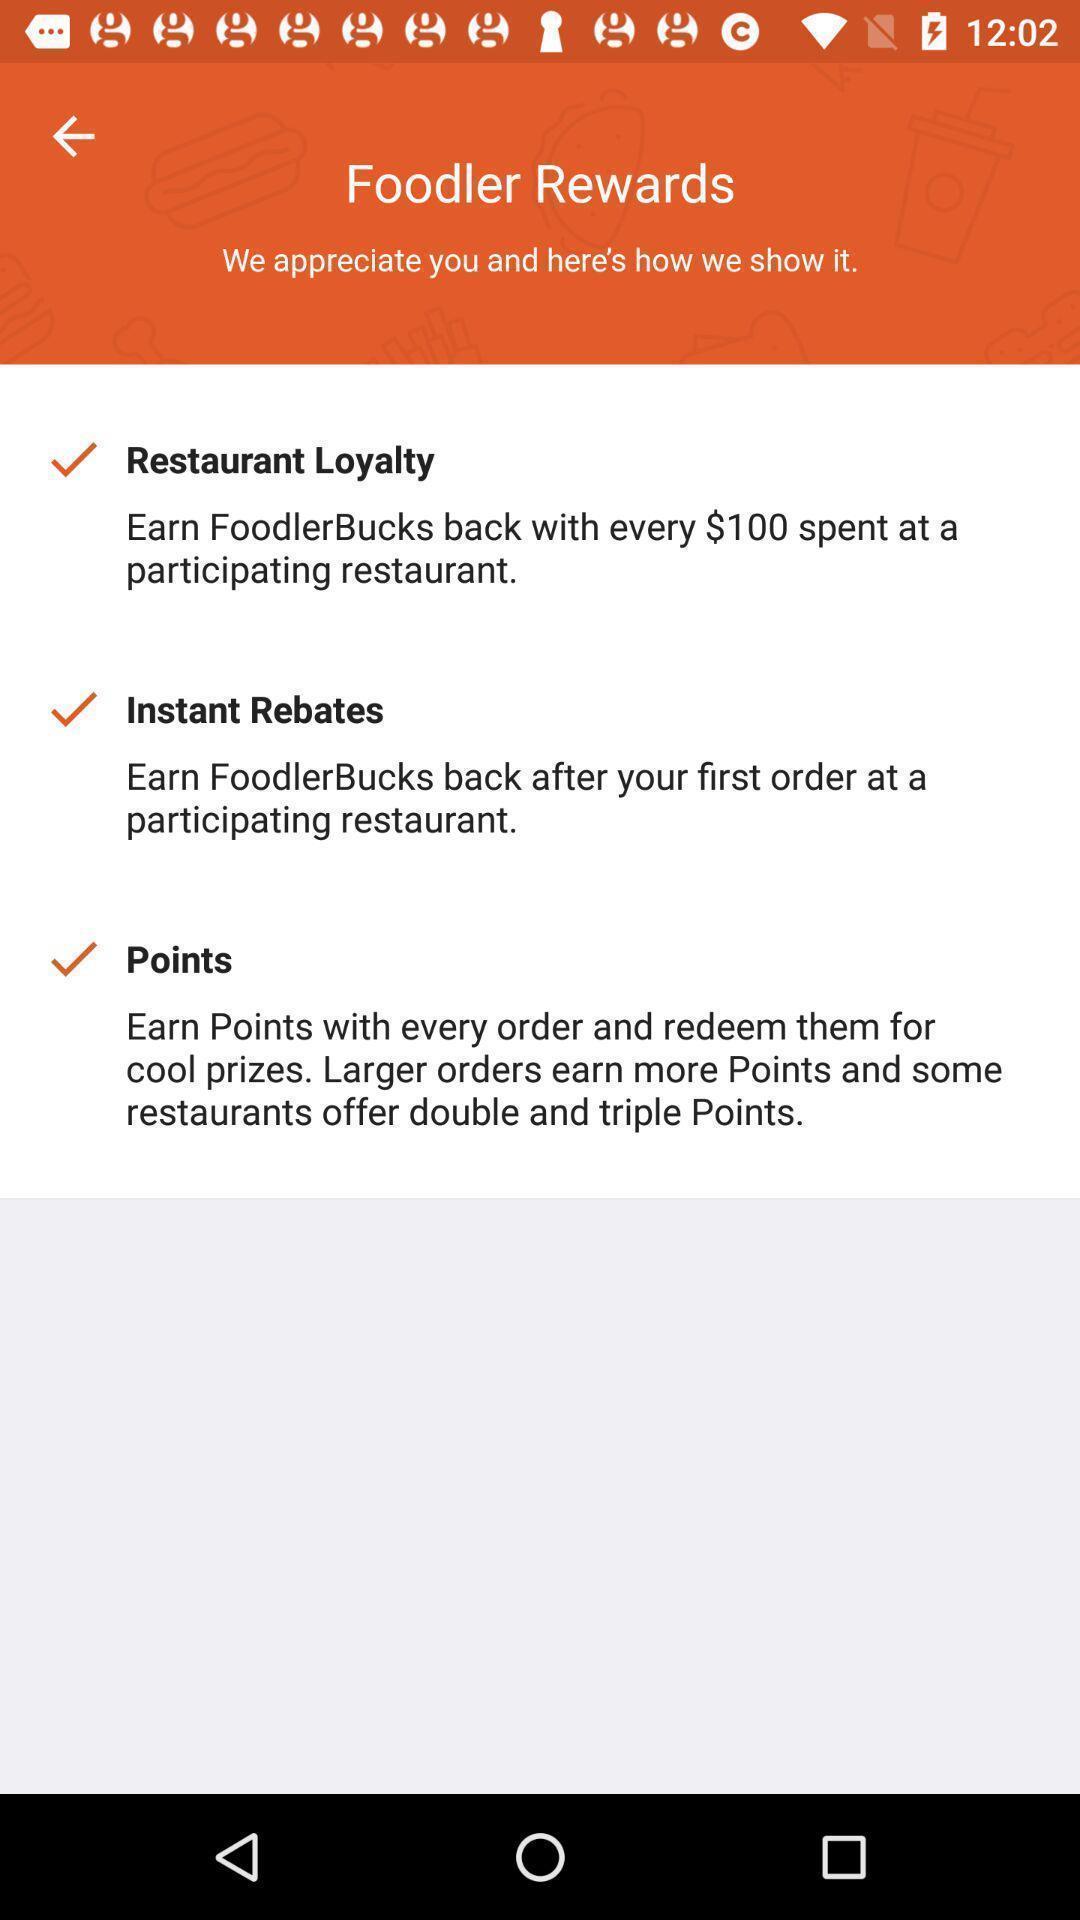Explain the elements present in this screenshot. Screen showing rewards page of a food app. 